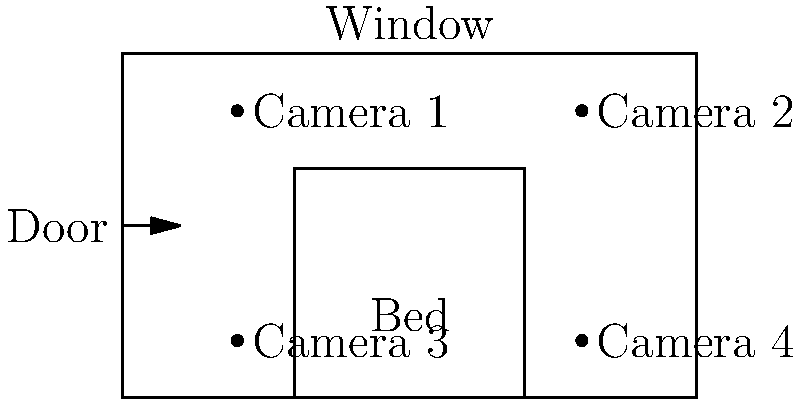Given the schematic of a luxury hotel room designed for influencer content creation, which camera position would likely capture the best lighting and background for social media posts? To determine the optimal camera position for influencer content creation, we need to consider several factors:

1. Natural lighting: The window is located at the top of the schematic, which is typically the best source of natural light.

2. Background elements: The bed is a key element in hotel room photography, often serving as a focal point.

3. Depth and perspective: A good shot should show depth and multiple elements of the room.

4. Avoid obstructions: The camera should have a clear view of the main elements without being blocked by furniture or walls.

Analyzing the four camera positions:

Camera 1: Located near the door, it captures the bed and window but might be too close to the wall.
Camera 2: Positioned opposite Camera 1, it offers a view of the bed with the window as a backdrop.
Camera 3: Located at the foot of the bed, it may not capture enough of the room's features.
Camera 4: Positioned at the foot of the bed on the opposite side, it offers a similar view to Camera 3.

Camera 2 appears to be the optimal choice because:
- It captures natural light from the window
- It includes the bed as a key element
- It provides depth by showing the entire length of the room
- It offers an unobstructed view of the room's main features
Answer: Camera 2 